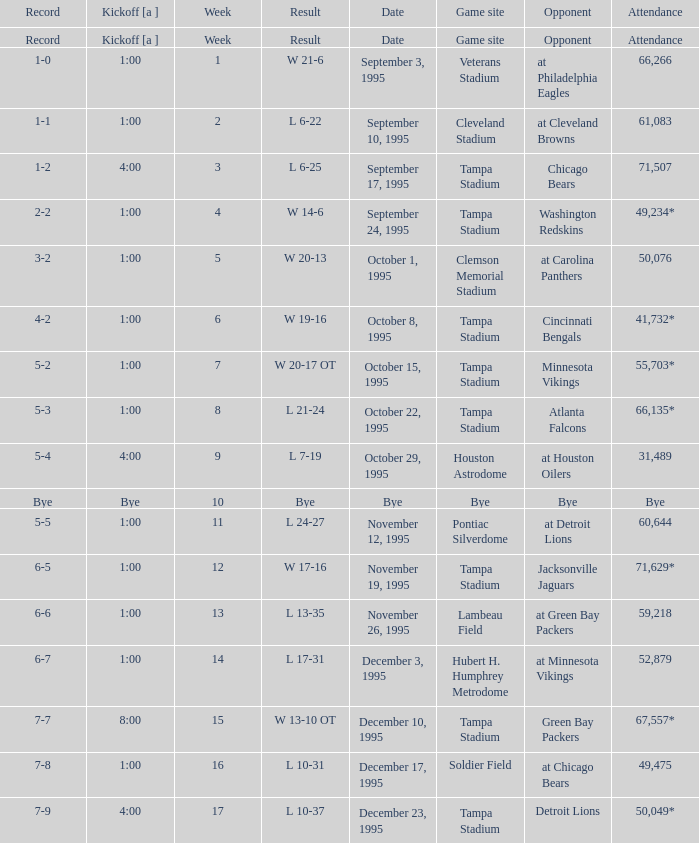Who did the Tampa Bay Buccaneers play on december 23, 1995? Detroit Lions. 